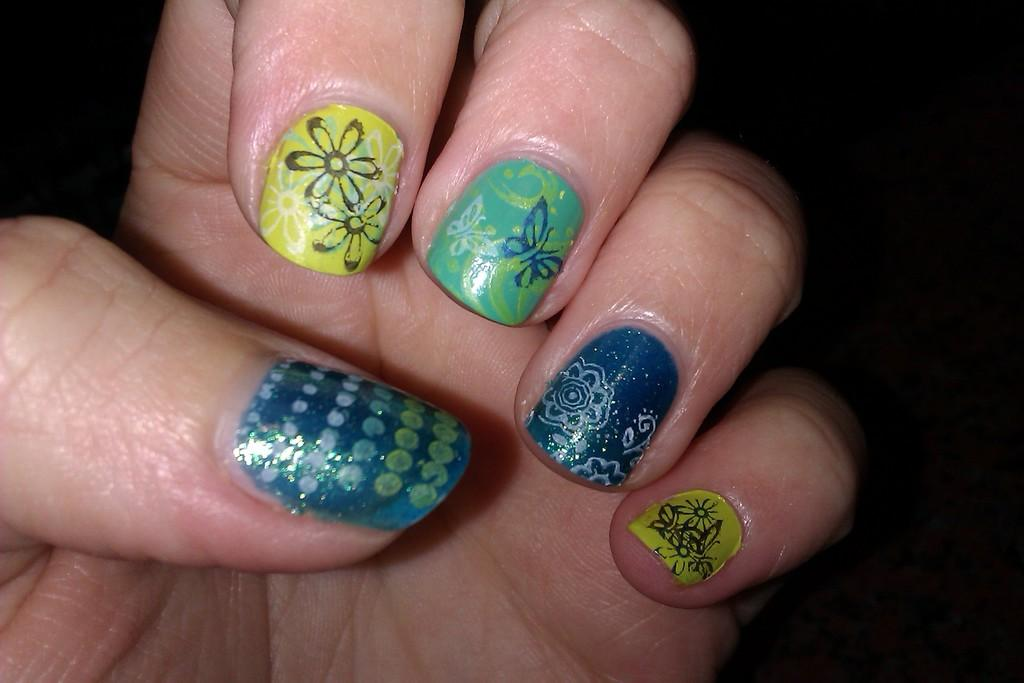What part of a person's body is visible in the image? There is a person's hand in the image. What can be observed about the nails on the hand? The nails on the hand have nail painting. What is the color or tone of the background in the image? The background of the image is dark. What type of addition problem is being solved on the hand in the image? There is no addition problem or any mathematical equation present on the hand in the image. 